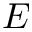<formula> <loc_0><loc_0><loc_500><loc_500>E</formula> 